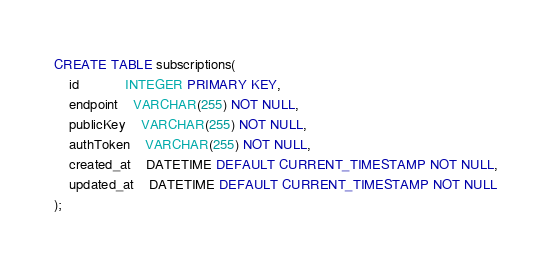Convert code to text. <code><loc_0><loc_0><loc_500><loc_500><_SQL_>CREATE TABLE subscriptions(
	id			INTEGER PRIMARY KEY,
	endpoint	VARCHAR(255) NOT NULL,
	publicKey	VARCHAR(255) NOT NULL,
	authToken	VARCHAR(255) NOT NULL,
	created_at	DATETIME DEFAULT CURRENT_TIMESTAMP NOT NULL,
	updated_at	DATETIME DEFAULT CURRENT_TIMESTAMP NOT NULL
);
</code> 